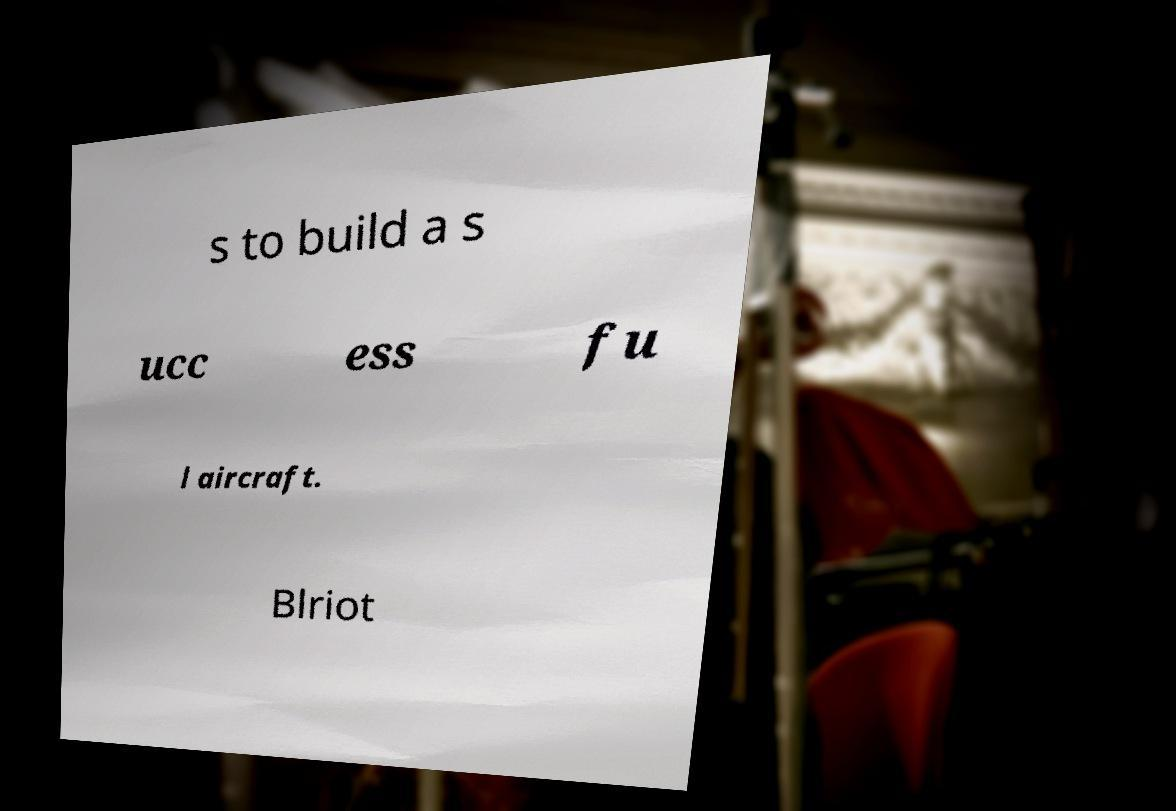There's text embedded in this image that I need extracted. Can you transcribe it verbatim? s to build a s ucc ess fu l aircraft. Blriot 